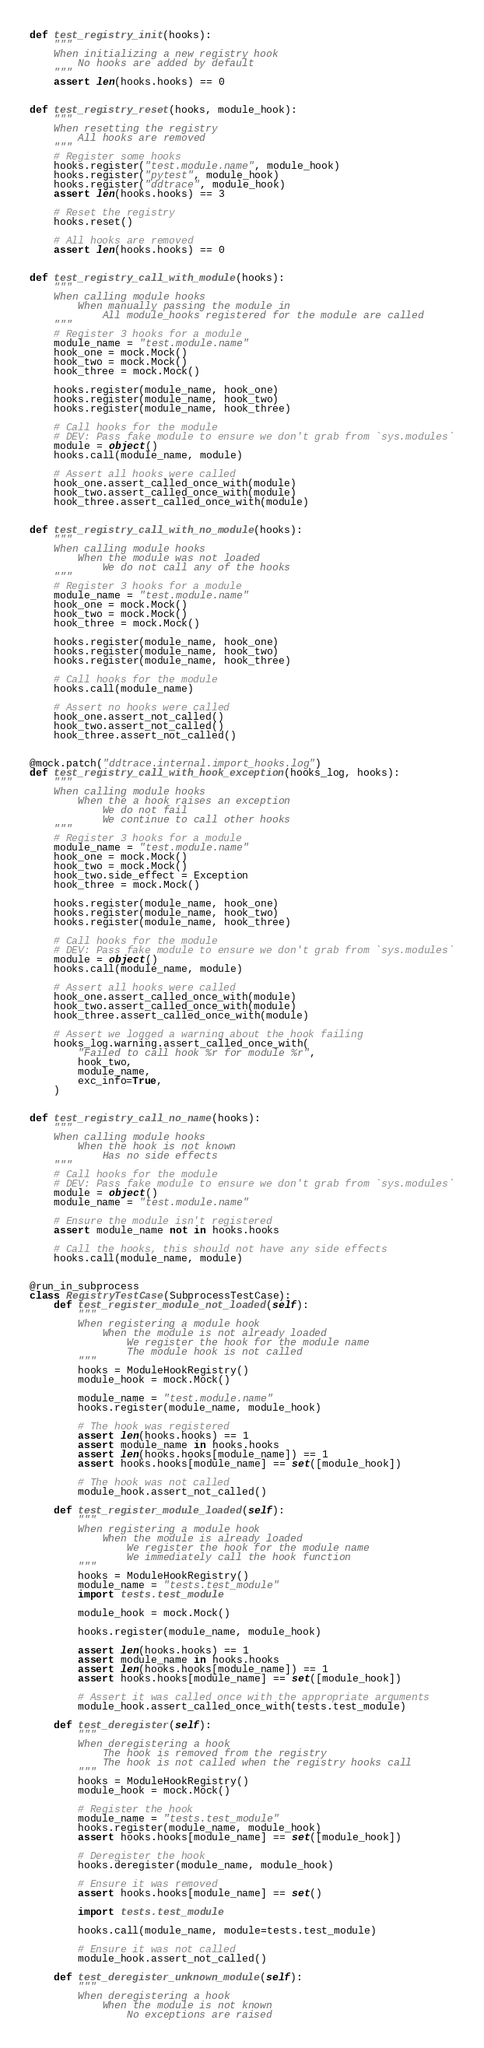Convert code to text. <code><loc_0><loc_0><loc_500><loc_500><_Python_>

def test_registry_init(hooks):
    """
    When initializing a new registry hook
        No hooks are added by default
    """
    assert len(hooks.hooks) == 0


def test_registry_reset(hooks, module_hook):
    """
    When resetting the registry
        All hooks are removed
    """
    # Register some hooks
    hooks.register("test.module.name", module_hook)
    hooks.register("pytest", module_hook)
    hooks.register("ddtrace", module_hook)
    assert len(hooks.hooks) == 3

    # Reset the registry
    hooks.reset()

    # All hooks are removed
    assert len(hooks.hooks) == 0


def test_registry_call_with_module(hooks):
    """
    When calling module hooks
        When manually passing the module in
            All module_hooks registered for the module are called
    """
    # Register 3 hooks for a module
    module_name = "test.module.name"
    hook_one = mock.Mock()
    hook_two = mock.Mock()
    hook_three = mock.Mock()

    hooks.register(module_name, hook_one)
    hooks.register(module_name, hook_two)
    hooks.register(module_name, hook_three)

    # Call hooks for the module
    # DEV: Pass fake module to ensure we don't grab from `sys.modules`
    module = object()
    hooks.call(module_name, module)

    # Assert all hooks were called
    hook_one.assert_called_once_with(module)
    hook_two.assert_called_once_with(module)
    hook_three.assert_called_once_with(module)


def test_registry_call_with_no_module(hooks):
    """
    When calling module hooks
        When the module was not loaded
            We do not call any of the hooks
    """
    # Register 3 hooks for a module
    module_name = "test.module.name"
    hook_one = mock.Mock()
    hook_two = mock.Mock()
    hook_three = mock.Mock()

    hooks.register(module_name, hook_one)
    hooks.register(module_name, hook_two)
    hooks.register(module_name, hook_three)

    # Call hooks for the module
    hooks.call(module_name)

    # Assert no hooks were called
    hook_one.assert_not_called()
    hook_two.assert_not_called()
    hook_three.assert_not_called()


@mock.patch("ddtrace.internal.import_hooks.log")
def test_registry_call_with_hook_exception(hooks_log, hooks):
    """
    When calling module hooks
        When the a hook raises an exception
            We do not fail
            We continue to call other hooks
    """
    # Register 3 hooks for a module
    module_name = "test.module.name"
    hook_one = mock.Mock()
    hook_two = mock.Mock()
    hook_two.side_effect = Exception
    hook_three = mock.Mock()

    hooks.register(module_name, hook_one)
    hooks.register(module_name, hook_two)
    hooks.register(module_name, hook_three)

    # Call hooks for the module
    # DEV: Pass fake module to ensure we don't grab from `sys.modules`
    module = object()
    hooks.call(module_name, module)

    # Assert all hooks were called
    hook_one.assert_called_once_with(module)
    hook_two.assert_called_once_with(module)
    hook_three.assert_called_once_with(module)

    # Assert we logged a warning about the hook failing
    hooks_log.warning.assert_called_once_with(
        "Failed to call hook %r for module %r",
        hook_two,
        module_name,
        exc_info=True,
    )


def test_registry_call_no_name(hooks):
    """
    When calling module hooks
        When the hook is not known
            Has no side effects
    """
    # Call hooks for the module
    # DEV: Pass fake module to ensure we don't grab from `sys.modules`
    module = object()
    module_name = "test.module.name"

    # Ensure the module isn't registered
    assert module_name not in hooks.hooks

    # Call the hooks, this should not have any side effects
    hooks.call(module_name, module)


@run_in_subprocess
class RegistryTestCase(SubprocessTestCase):
    def test_register_module_not_loaded(self):
        """
        When registering a module hook
            When the module is not already loaded
                We register the hook for the module name
                The module hook is not called
        """
        hooks = ModuleHookRegistry()
        module_hook = mock.Mock()

        module_name = "test.module.name"
        hooks.register(module_name, module_hook)

        # The hook was registered
        assert len(hooks.hooks) == 1
        assert module_name in hooks.hooks
        assert len(hooks.hooks[module_name]) == 1
        assert hooks.hooks[module_name] == set([module_hook])

        # The hook was not called
        module_hook.assert_not_called()

    def test_register_module_loaded(self):
        """
        When registering a module hook
            When the module is already loaded
                We register the hook for the module name
                We immediately call the hook function
        """
        hooks = ModuleHookRegistry()
        module_name = "tests.test_module"
        import tests.test_module

        module_hook = mock.Mock()

        hooks.register(module_name, module_hook)

        assert len(hooks.hooks) == 1
        assert module_name in hooks.hooks
        assert len(hooks.hooks[module_name]) == 1
        assert hooks.hooks[module_name] == set([module_hook])

        # Assert it was called once with the appropriate arguments
        module_hook.assert_called_once_with(tests.test_module)

    def test_deregister(self):
        """
        When deregistering a hook
            The hook is removed from the registry
            The hook is not called when the registry hooks call
        """
        hooks = ModuleHookRegistry()
        module_hook = mock.Mock()

        # Register the hook
        module_name = "tests.test_module"
        hooks.register(module_name, module_hook)
        assert hooks.hooks[module_name] == set([module_hook])

        # Deregister the hook
        hooks.deregister(module_name, module_hook)

        # Ensure it was removed
        assert hooks.hooks[module_name] == set()

        import tests.test_module

        hooks.call(module_name, module=tests.test_module)

        # Ensure it was not called
        module_hook.assert_not_called()

    def test_deregister_unknown_module(self):
        """
        When deregistering a hook
            When the module is not known
                No exceptions are raised</code> 